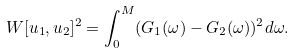Convert formula to latex. <formula><loc_0><loc_0><loc_500><loc_500>W [ u _ { 1 } , u _ { 2 } ] ^ { 2 } = \int _ { 0 } ^ { M } ( G _ { 1 } ( \omega ) - G _ { 2 } ( \omega ) ) ^ { 2 } d \omega .</formula> 